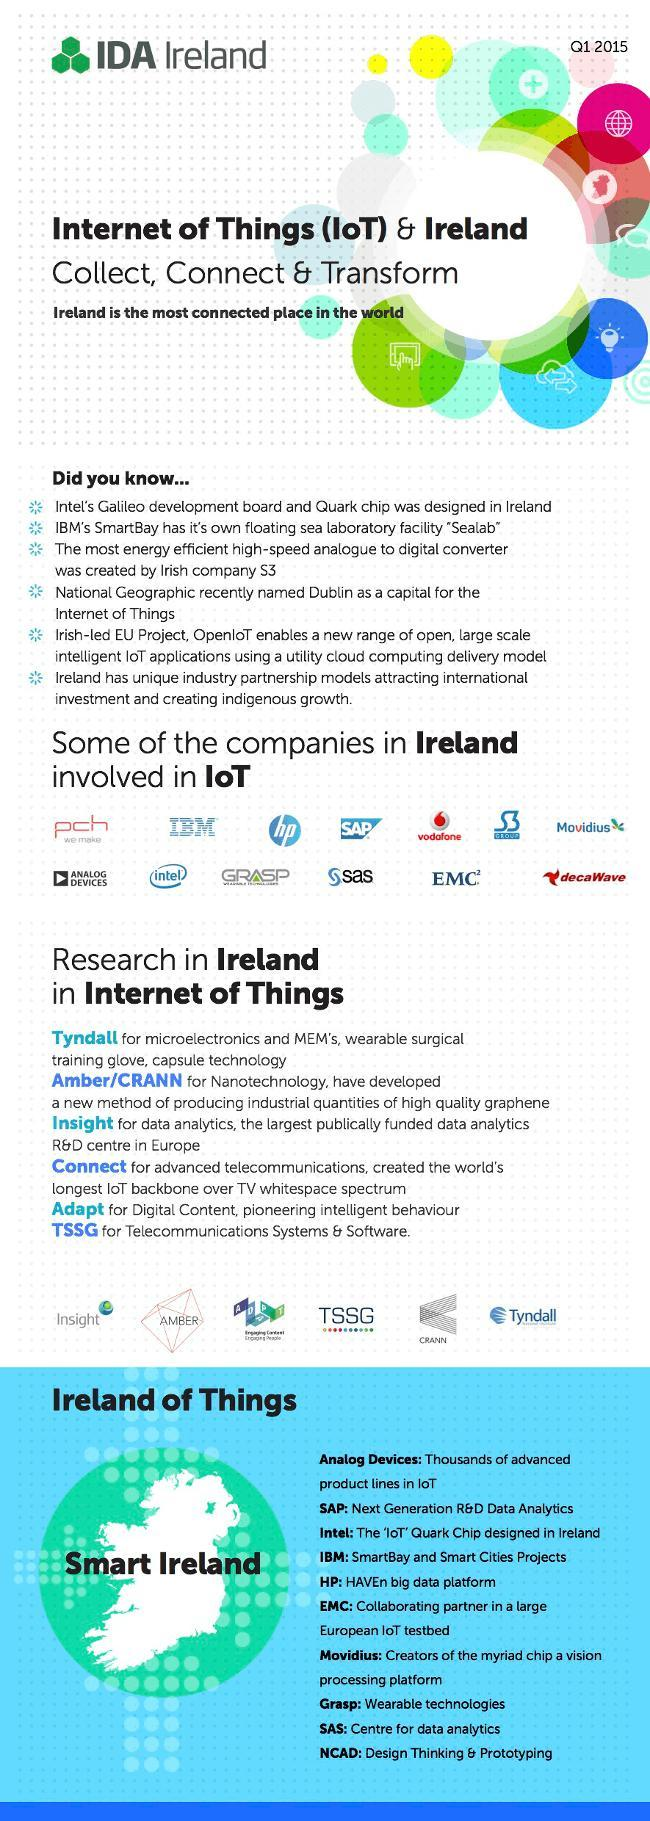How many companies in Ireland are involved in IoT?
Answer the question with a short phrase. 13 